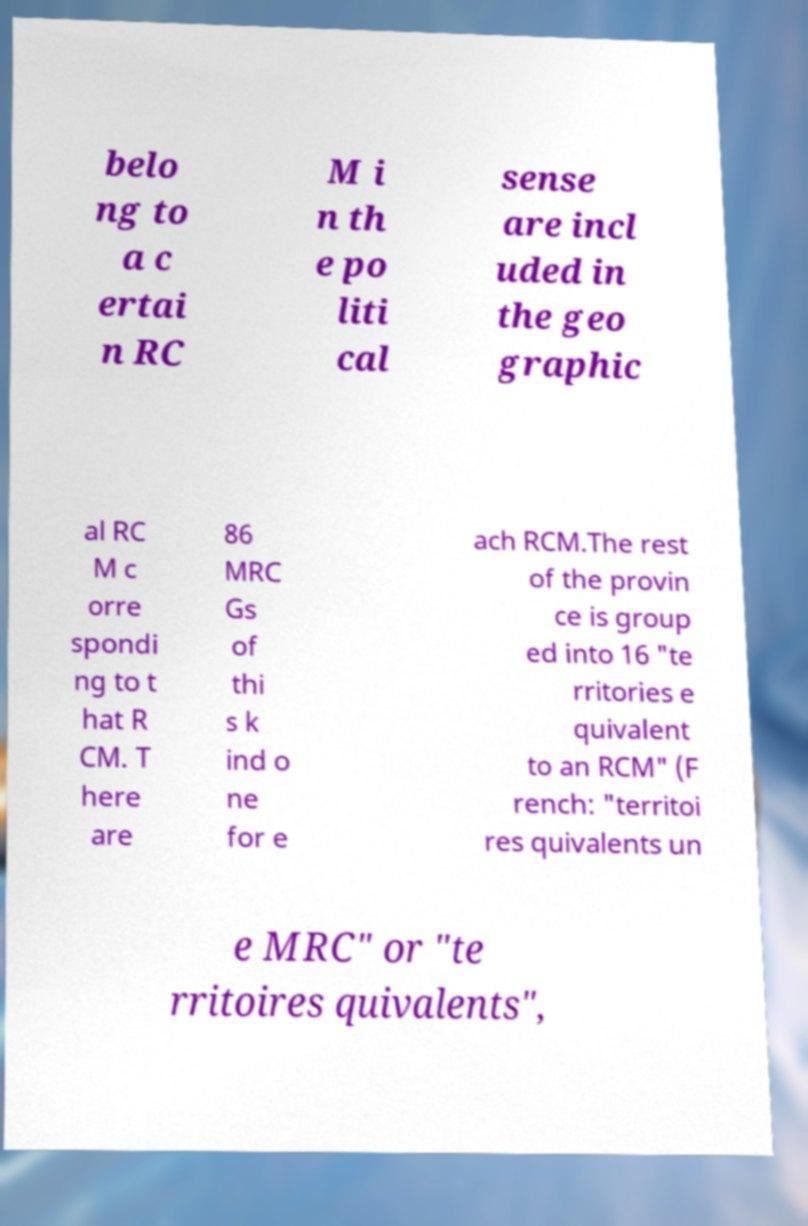Could you extract and type out the text from this image? belo ng to a c ertai n RC M i n th e po liti cal sense are incl uded in the geo graphic al RC M c orre spondi ng to t hat R CM. T here are 86 MRC Gs of thi s k ind o ne for e ach RCM.The rest of the provin ce is group ed into 16 "te rritories e quivalent to an RCM" (F rench: "territoi res quivalents un e MRC" or "te rritoires quivalents", 